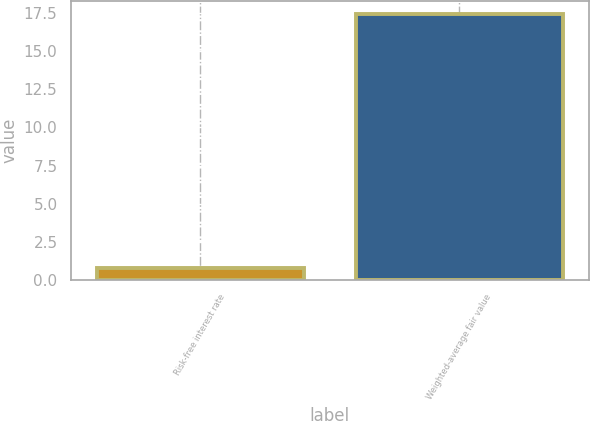Convert chart to OTSL. <chart><loc_0><loc_0><loc_500><loc_500><bar_chart><fcel>Risk-free interest rate<fcel>Weighted-average fair value<nl><fcel>0.75<fcel>17.46<nl></chart> 